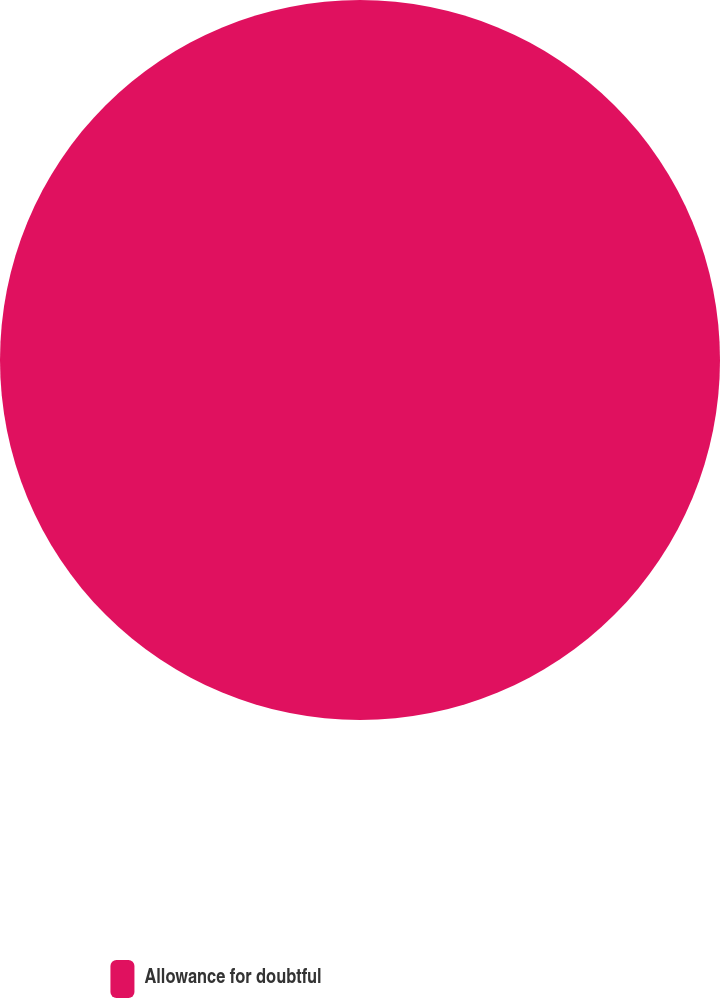<chart> <loc_0><loc_0><loc_500><loc_500><pie_chart><fcel>Allowance for doubtful<nl><fcel>100.0%<nl></chart> 